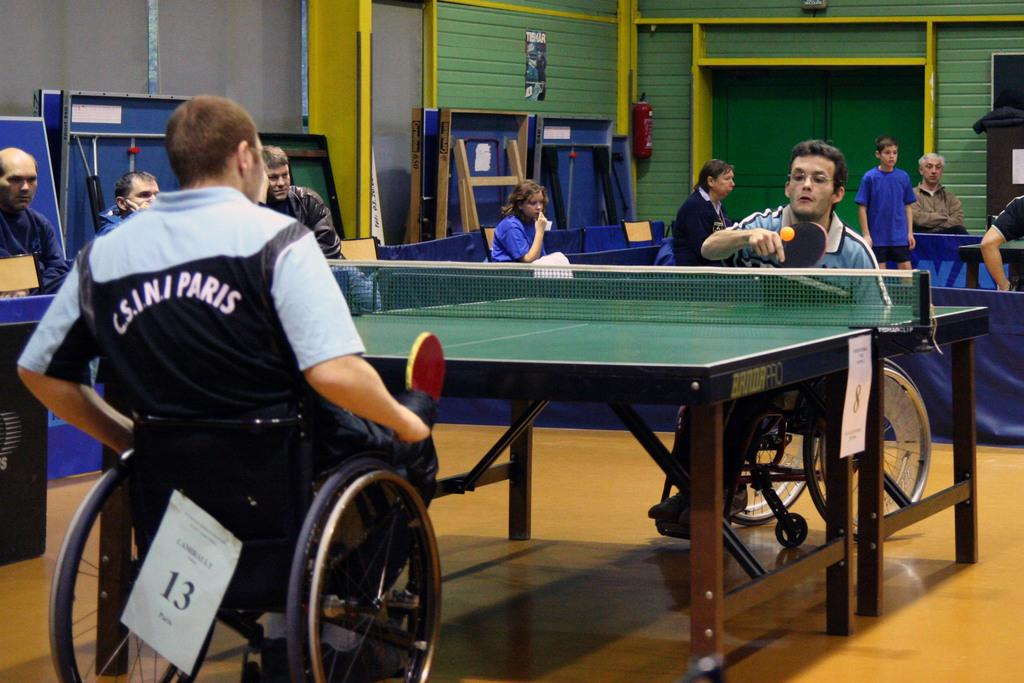What are the two men in the image doing? The two men in the image are sitting on wheelchairs and holding rackets. What might the men be participating in, based on the objects they are holding? The men might be participating in a game, such as table tennis, as they are holding rackets. What can be seen in the background of the image? There are people and tables visible in the background of the image. What type of zipper can be seen on the men's clothing in the image? There is no mention of zippers or clothing in the provided facts, so it cannot be determined from the image. 